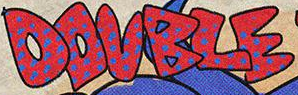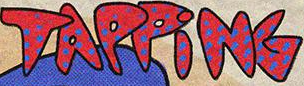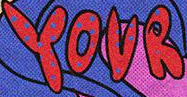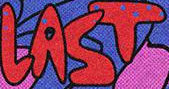Identify the words shown in these images in order, separated by a semicolon. DOUBLE; TAPPiNG; YOUR; LAST 